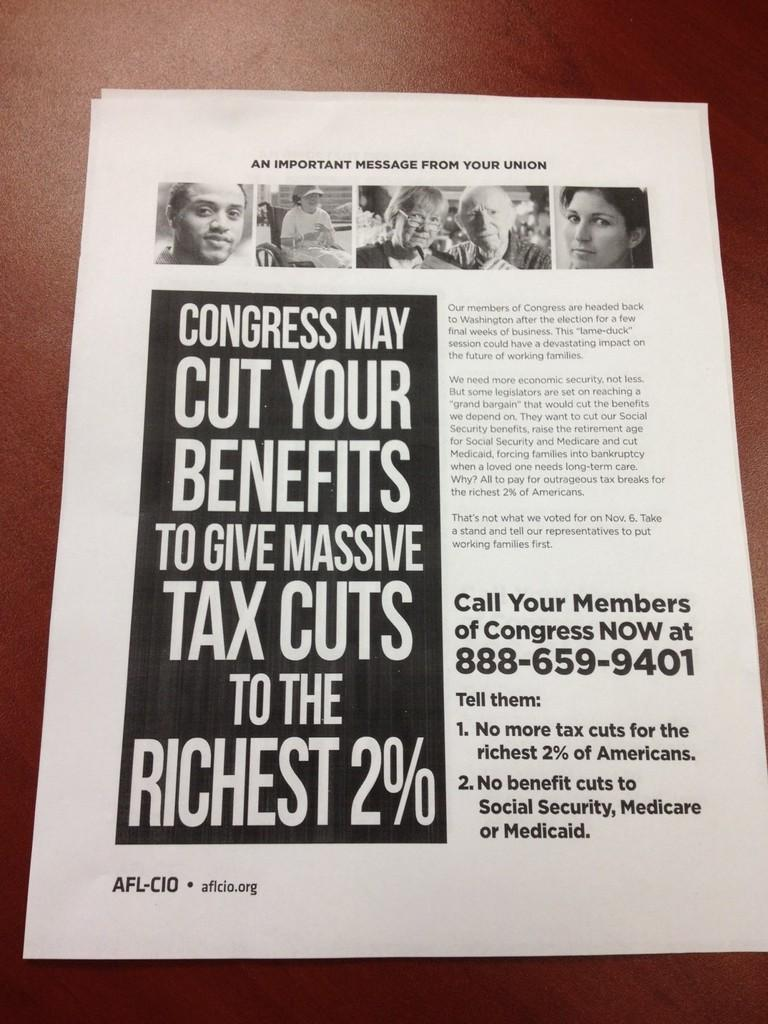<image>
Summarize the visual content of the image. A black and white page with the heading of "An Important Message from your Union" sits on a table. 